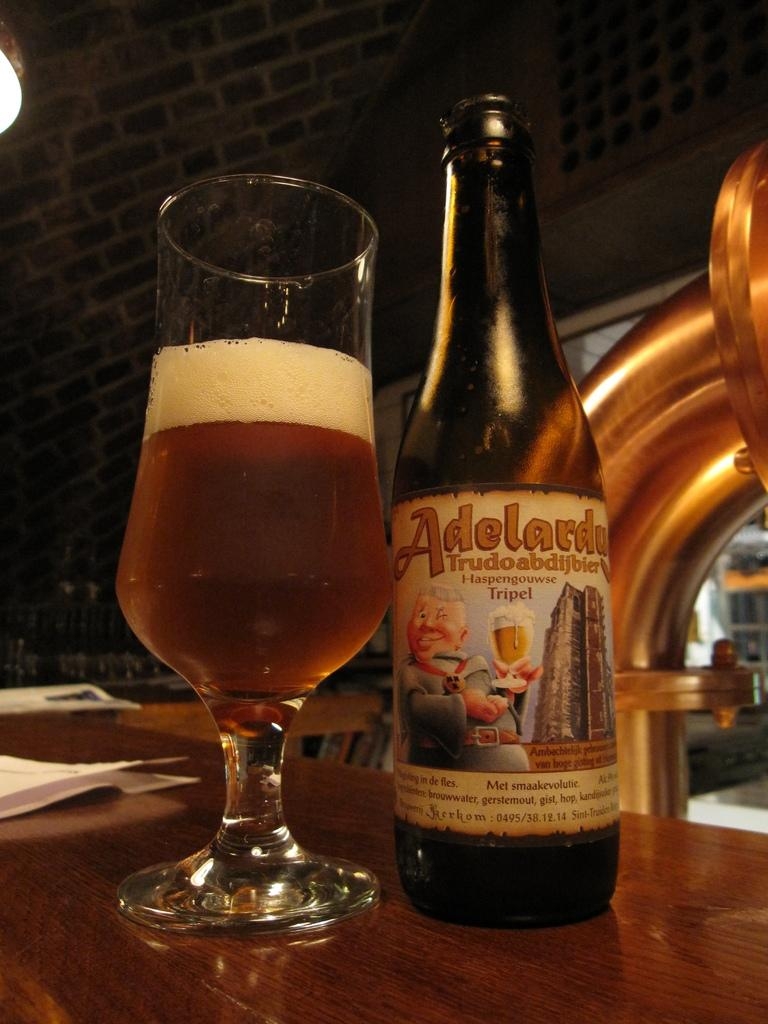Provide a one-sentence caption for the provided image. An Adelardu bottle sits next to a glass filled with amber liquid. 